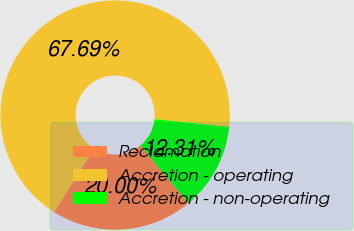<chart> <loc_0><loc_0><loc_500><loc_500><pie_chart><fcel>Reclamation<fcel>Accretion - operating<fcel>Accretion - non-operating<nl><fcel>20.0%<fcel>67.69%<fcel>12.31%<nl></chart> 